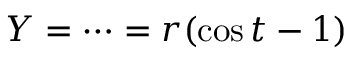<formula> <loc_0><loc_0><loc_500><loc_500>Y = \cdots = r ( \cos t - 1 )</formula> 